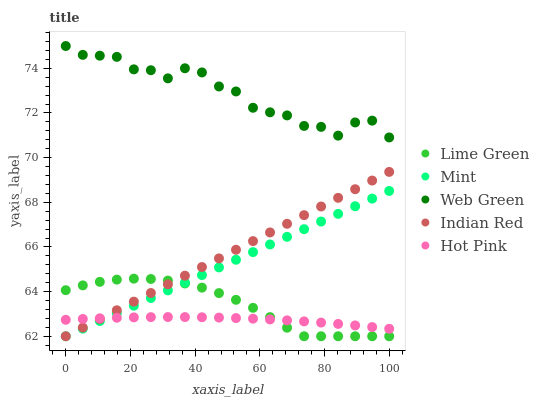Does Hot Pink have the minimum area under the curve?
Answer yes or no. Yes. Does Web Green have the maximum area under the curve?
Answer yes or no. Yes. Does Lime Green have the minimum area under the curve?
Answer yes or no. No. Does Lime Green have the maximum area under the curve?
Answer yes or no. No. Is Mint the smoothest?
Answer yes or no. Yes. Is Web Green the roughest?
Answer yes or no. Yes. Is Hot Pink the smoothest?
Answer yes or no. No. Is Hot Pink the roughest?
Answer yes or no. No. Does Mint have the lowest value?
Answer yes or no. Yes. Does Hot Pink have the lowest value?
Answer yes or no. No. Does Web Green have the highest value?
Answer yes or no. Yes. Does Lime Green have the highest value?
Answer yes or no. No. Is Hot Pink less than Web Green?
Answer yes or no. Yes. Is Web Green greater than Mint?
Answer yes or no. Yes. Does Indian Red intersect Hot Pink?
Answer yes or no. Yes. Is Indian Red less than Hot Pink?
Answer yes or no. No. Is Indian Red greater than Hot Pink?
Answer yes or no. No. Does Hot Pink intersect Web Green?
Answer yes or no. No. 